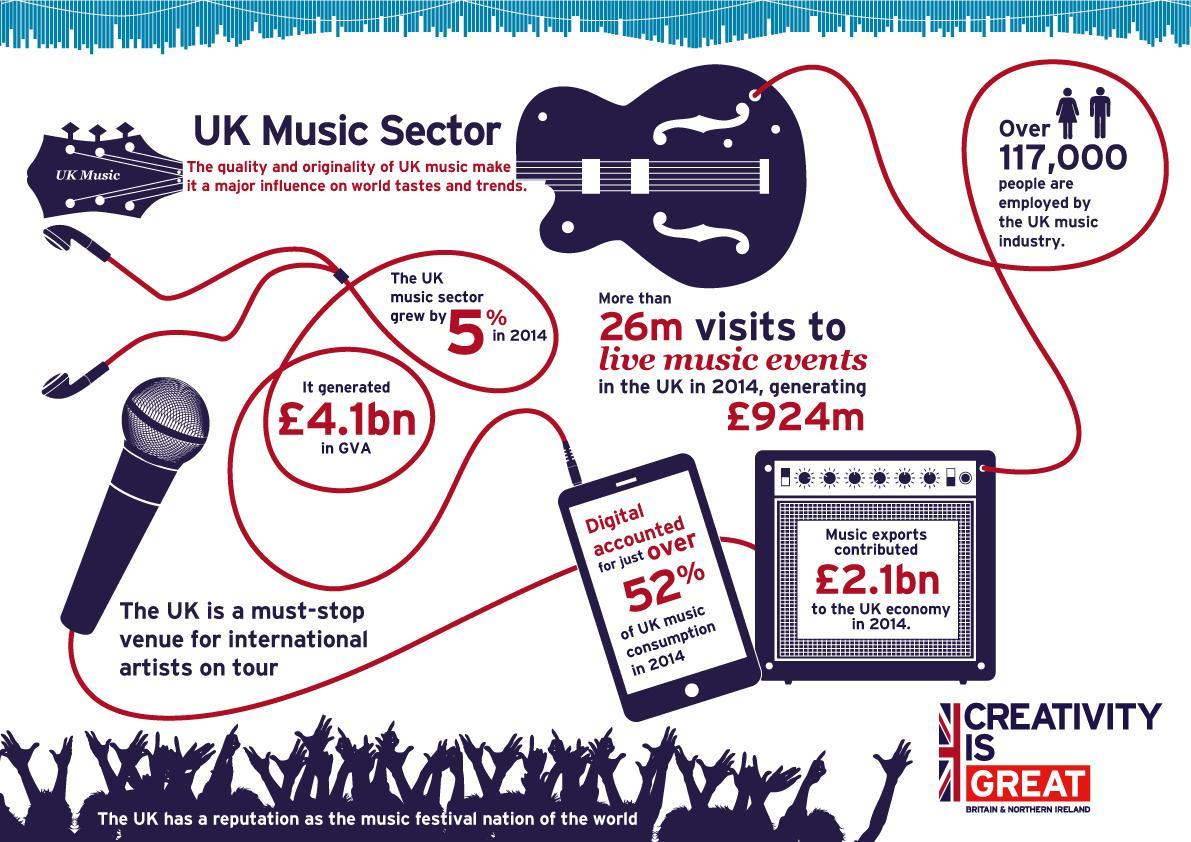How much is the revenue generated by live music events in UK in 2014?
Answer the question with a short phrase. £924m How many people are employed by the UK music industry in 2014? Over 117,000 